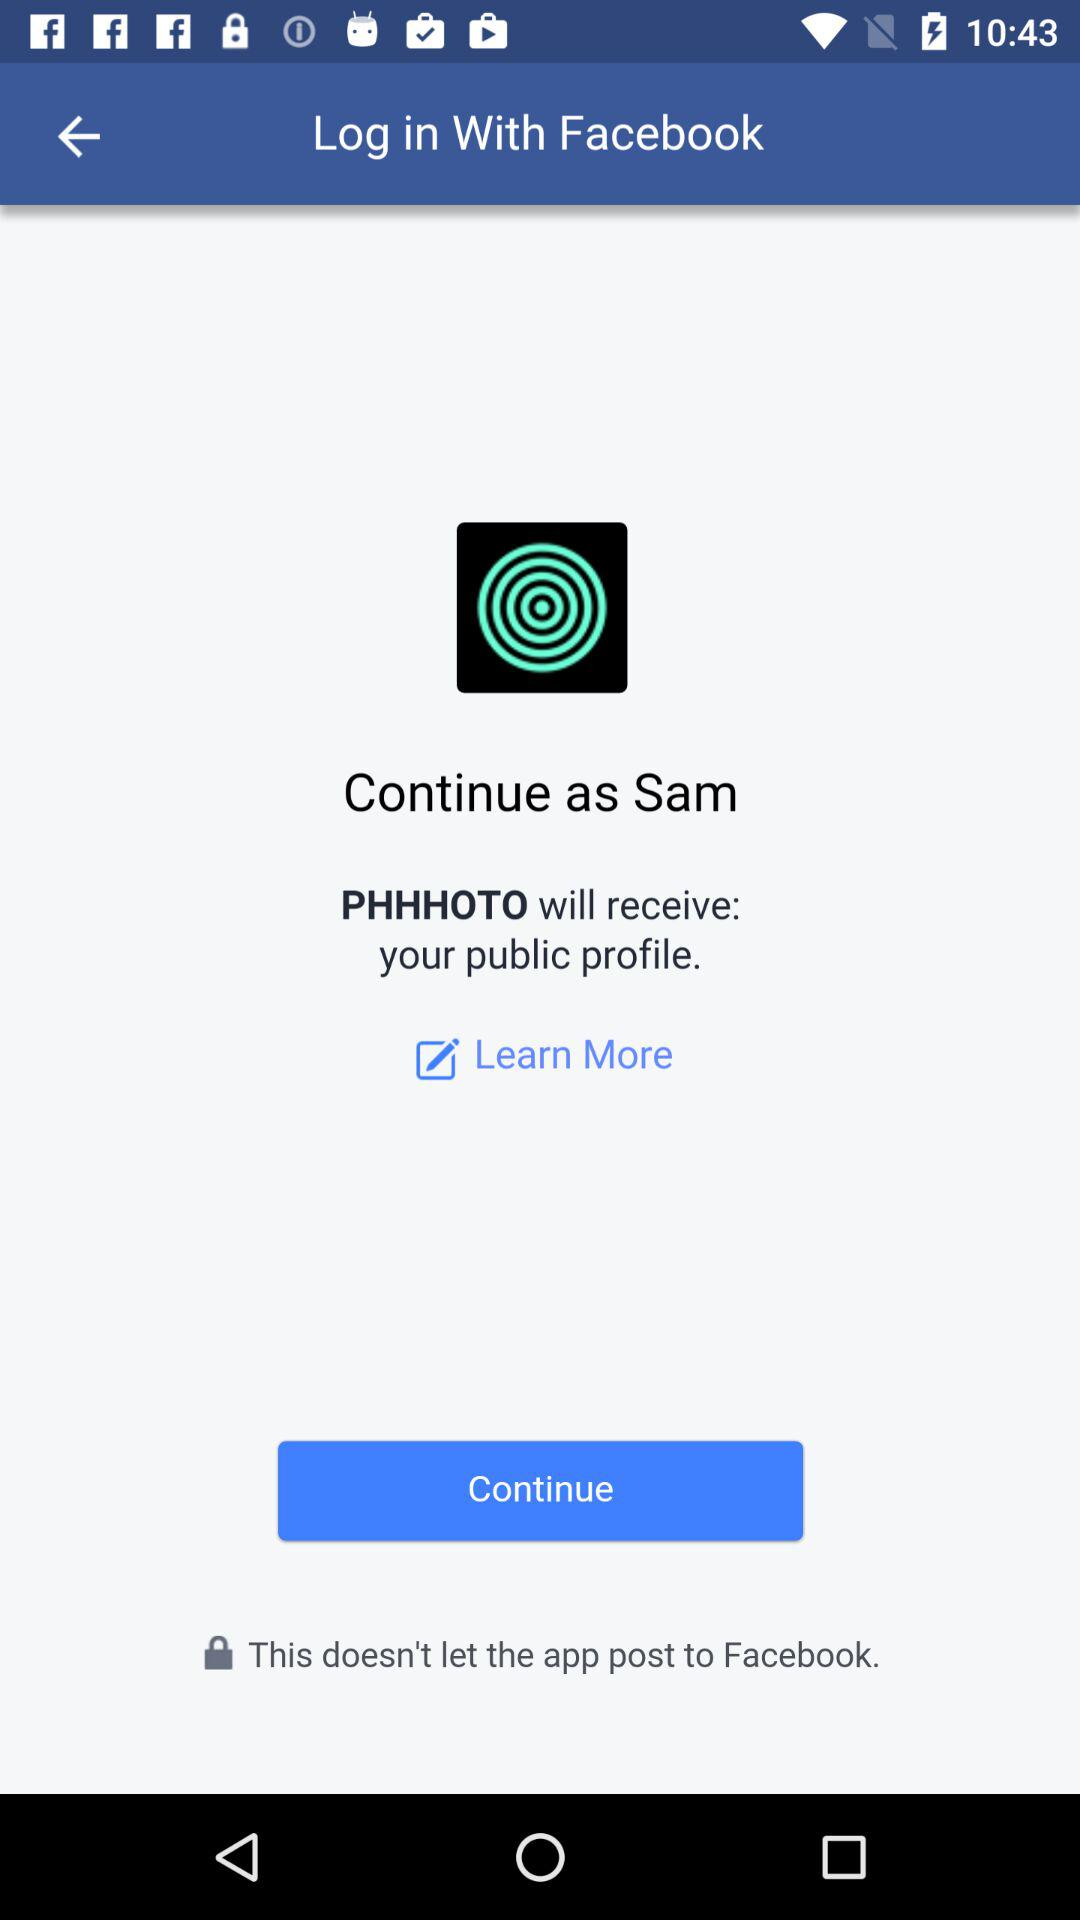What application is asking for permission?
Answer the question using a single word or phrase. The application asking for permission is "PHHHOTO." 